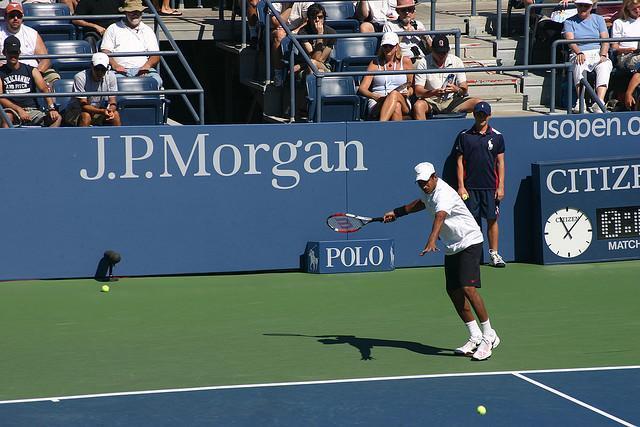How many people are visible?
Give a very brief answer. 9. 